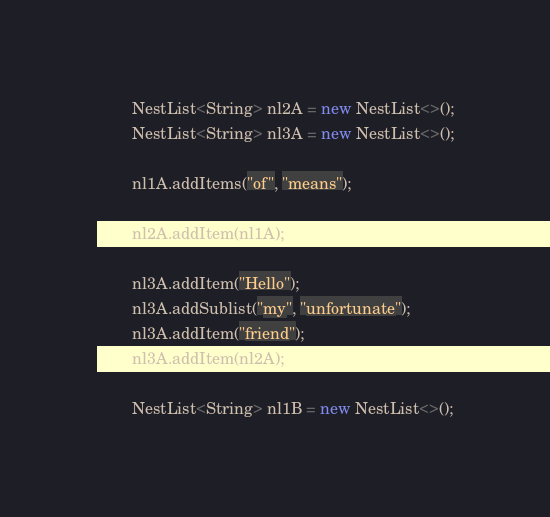Convert code to text. <code><loc_0><loc_0><loc_500><loc_500><_Java_>		NestList<String> nl2A = new NestList<>();
		NestList<String> nl3A = new NestList<>();
		
		nl1A.addItems("of", "means");
		
		nl2A.addItem(nl1A);
		
		nl3A.addItem("Hello");
		nl3A.addSublist("my", "unfortunate");
		nl3A.addItem("friend");
		nl3A.addItem(nl2A);
		
		NestList<String> nl1B = new NestList<>();</code> 